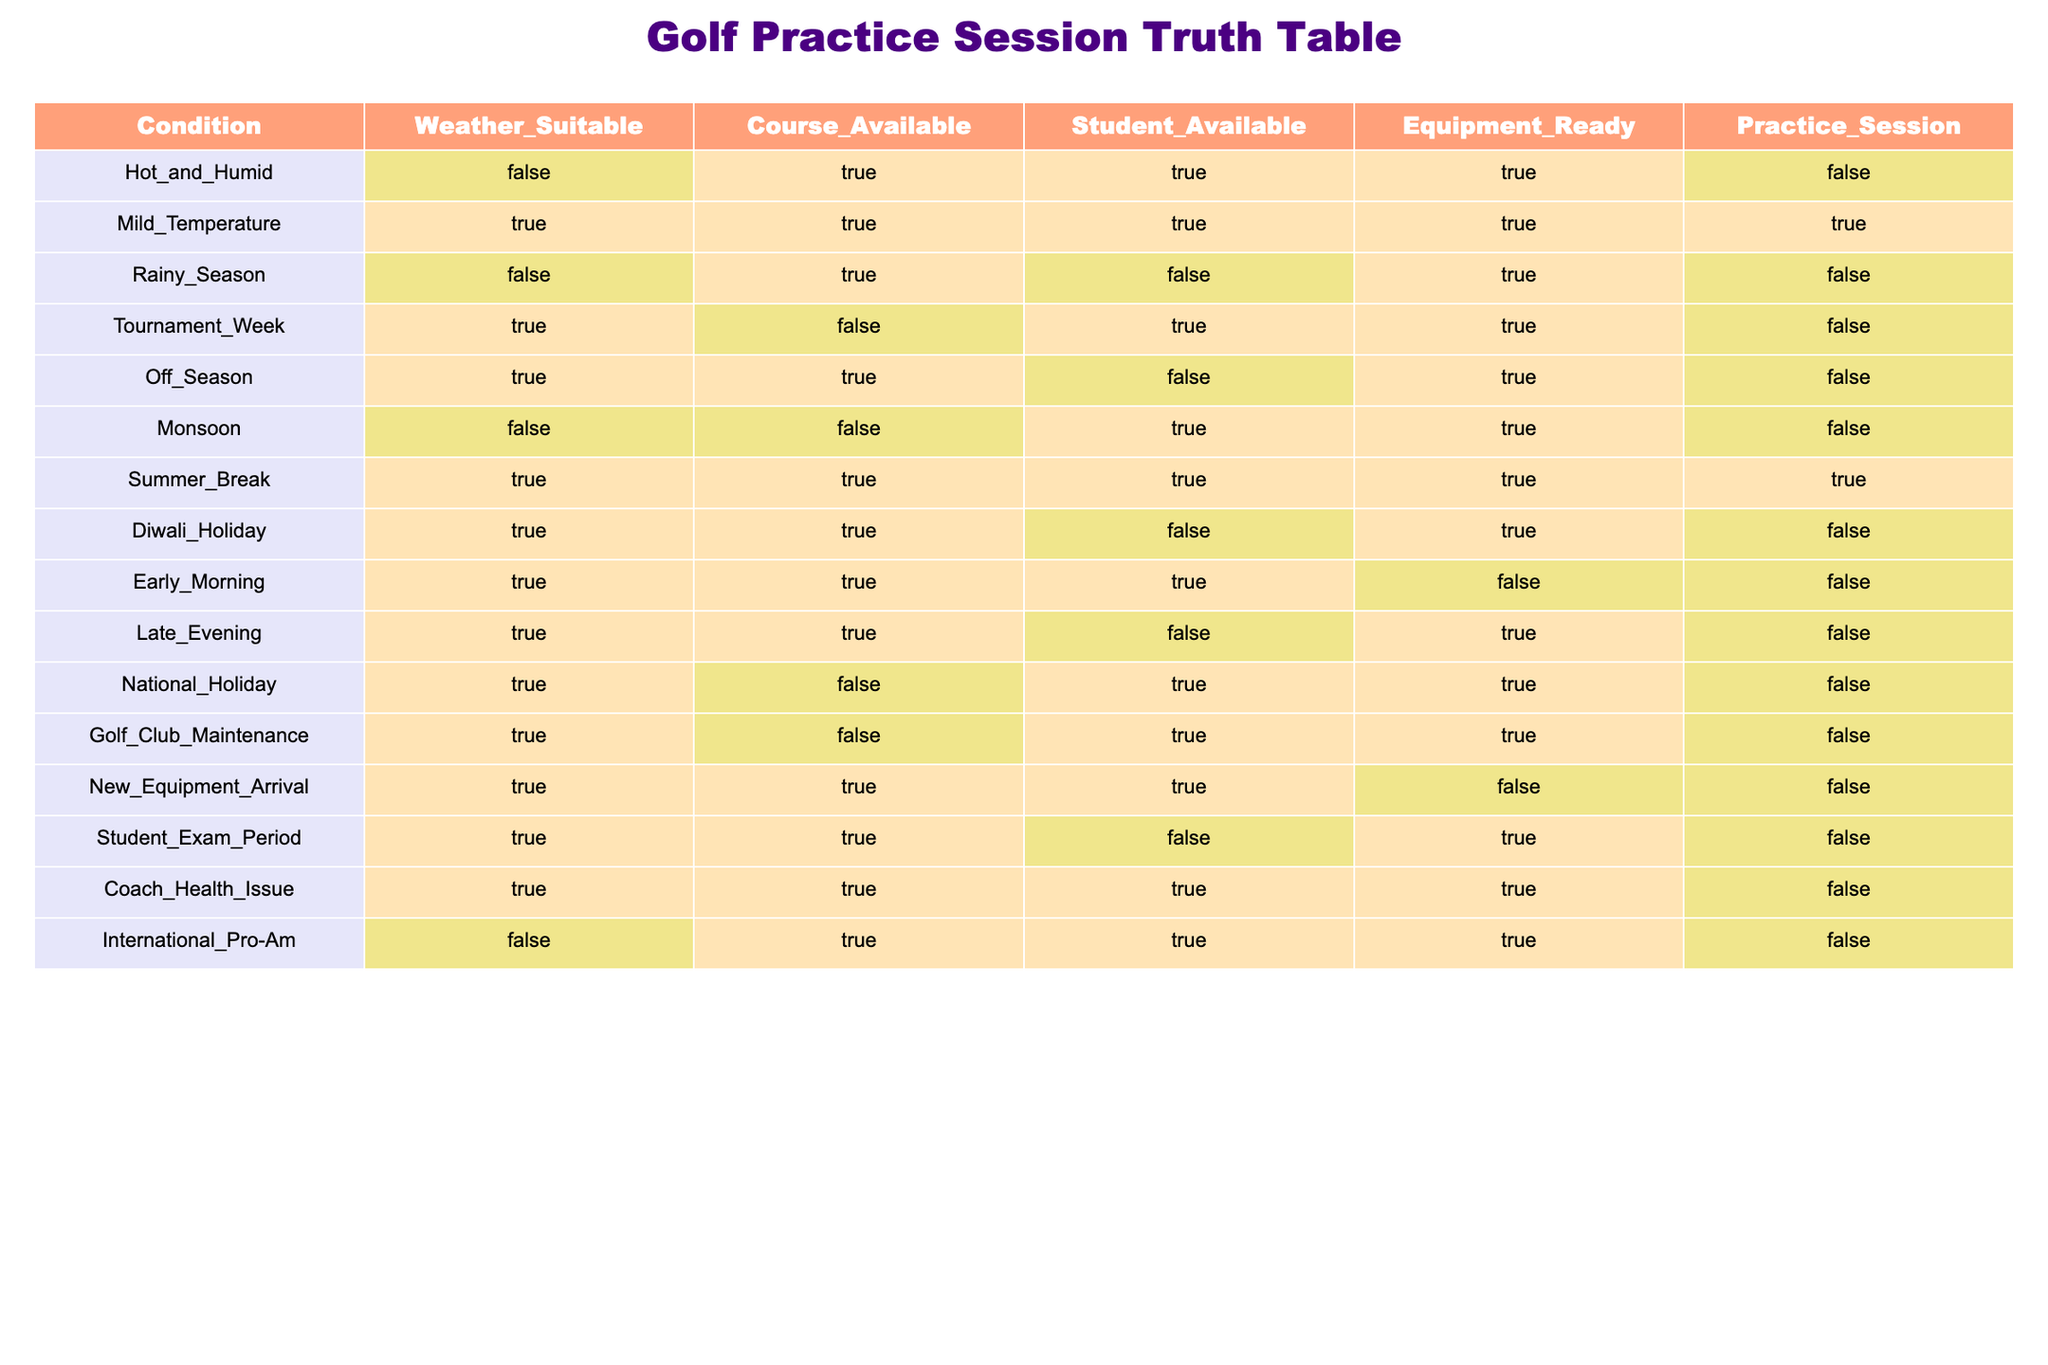What conditions lead to a suitable practice session? A practice session is suitable if the values for Weather_Suitable, Course_Available, Student_Available, and Equipment_Ready are all TRUE. From the table, we see that this occurs only under the Mild_Temperature and Summer_Break conditions.
Answer: Mild_Temperature and Summer_Break Is there a practice session during the Rainy_Season? The Rainy_Season has Weather_Suitable as FALSE, so a practice session cannot occur under this condition regardless of other factors.
Answer: No How many conditions have Equipment_Ready as FALSE? We need to count all the rows where Equipment_Ready is FALSE. In the table, the rows that meet this criterion are Hot_and_Humid, Rainy_Season, Early_Morning, and Student_Exam_Period, making a total of 4.
Answer: 4 Which condition has the highest number of TRUE values across the columns? To find this condition, we check each condition's TRUE values across all four criteria (Weather_Suitable, Course_Available, Student_Available, Equipment_Ready). The condition with the most TRUEs is Summer_Break, which has all four values as TRUE, giving it the highest total.
Answer: Summer_Break Are there conditions where Course_Available is FALSE but practice sessions are still possible? Yes, we should look for rows where Course_Available is FALSE and practice sessions are TRUE. The Tournament_Week, National_Holiday, and Golf_Club_Maintenance meet this requirement; however, these practice sessions are marked as FALSE. Therefore, no conditions allow a practice session under these circumstances.
Answer: No In what scenarios do we have Student_Available as TRUE but no practice session? We need to identify the rows where Student_Available is TRUE and check the corresponding Practice_Session value. The conditions that meet this are Rainy_Season, Tournament_Week, Off_Season, and Student_Exam_Period, all of which have practice sessions marked as FALSE.
Answer: Rainy_Season, Tournament_Week, Off_Season, Student_Exam_Period What is the total number of conditions that have suitable weather? Count the number of rows with Weather_Suitable as TRUE. These conditions are Mild_Temperature, Tournament_Week, Off_Season, Summer_Break, Diwali_Holiday, Early_Morning, Late_Evening, National_Holiday, Golf_Club_Maintenance, Student_Exam_Period, and Coach_Health_Issue, resulting in 11 conditions.
Answer: 11 Is it possible to have both New_Equipment_Arrival and a practice session at the same time? Despite New_Equipment_Arrival having TRUE for Equipment_Ready, the Practice_Session value is FALSE. Therefore, it is not possible to have a practice session at this time.
Answer: No What is the average number of TRUE values for the conditions? We count how many conditions have TRUE values and the total number of TRUEs. After evaluating the conditions, we find that there are 22 TRUE values across the table and 14 conditions total, leading to an average of 22/14 = 1.57.
Answer: 1.57 